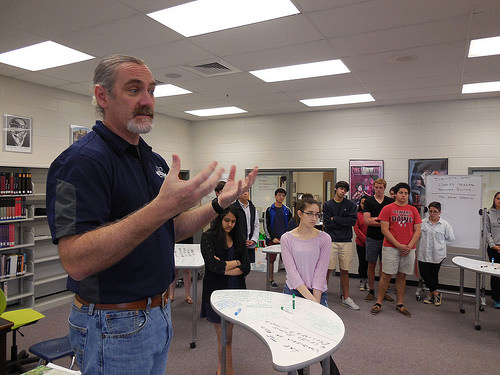<image>
Can you confirm if the woman is next to the chair? No. The woman is not positioned next to the chair. They are located in different areas of the scene. Is the man in front of the kid? Yes. The man is positioned in front of the kid, appearing closer to the camera viewpoint. 